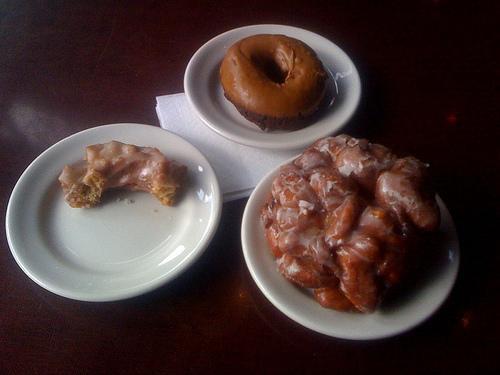How many doughnuts are shown?
Give a very brief answer. 3. 